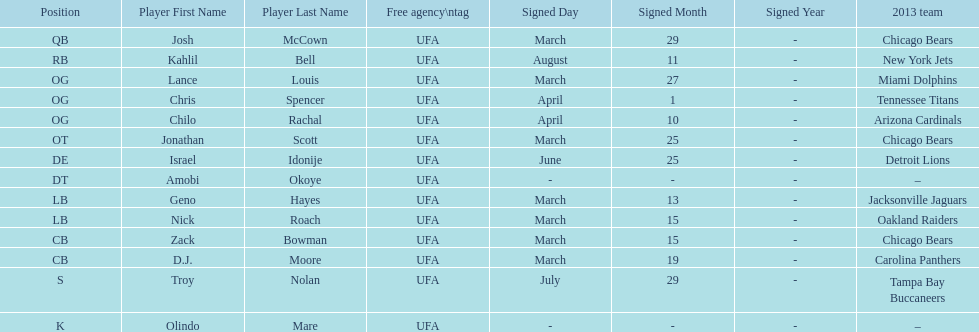How many players play cb or og? 5. 